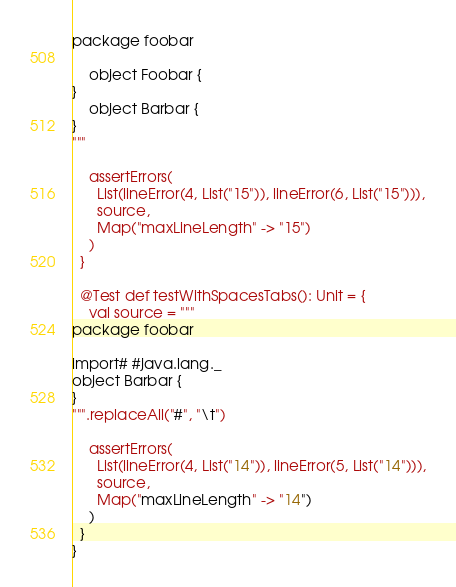Convert code to text. <code><loc_0><loc_0><loc_500><loc_500><_Scala_>package foobar

    object Foobar {
}
    object Barbar {
}
"""

    assertErrors(
      List(lineError(4, List("15")), lineError(6, List("15"))),
      source,
      Map("maxLineLength" -> "15")
    )
  }

  @Test def testWithSpacesTabs(): Unit = {
    val source = """
package foobar

import# #java.lang._
object Barbar {
}
""".replaceAll("#", "\t")

    assertErrors(
      List(lineError(4, List("14")), lineError(5, List("14"))),
      source,
      Map("maxLineLength" -> "14")
    )
  }
}
</code> 